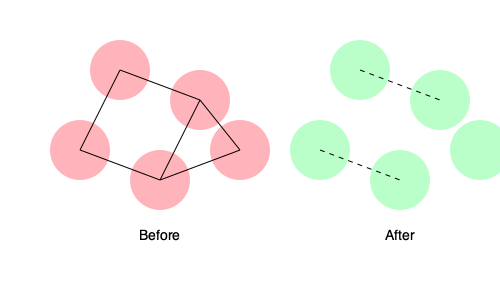Analyze the network topology changes before and after implementing social distancing measures. Calculate the reduction in network density and explain its implications for disease spread. To analyze the changes in network topology and calculate the reduction in network density:

1. Count the nodes and edges in each network:
   - Before: 5 nodes, 6 edges
   - After: 5 nodes, 2 edges

2. Calculate network density for each network using the formula:
   $$ \text{Density} = \frac{2E}{N(N-1)} $$
   Where $E$ is the number of edges and $N$ is the number of nodes.

3. Before social distancing:
   $$ \text{Density}_{\text{before}} = \frac{2 \times 6}{5(5-1)} = \frac{12}{20} = 0.6 $$

4. After social distancing:
   $$ \text{Density}_{\text{after}} = \frac{2 \times 2}{5(5-1)} = \frac{4}{20} = 0.2 $$

5. Calculate the reduction in network density:
   $$ \text{Reduction} = \text{Density}_{\text{before}} - \text{Density}_{\text{after}} = 0.6 - 0.2 = 0.4 $$

6. Calculate the percentage reduction:
   $$ \text{Percentage Reduction} = \frac{0.4}{0.6} \times 100\% \approx 66.67\% $$

Implications for disease spread:
- The significant reduction in network density (66.67%) indicates fewer connections between individuals.
- Fewer connections mean fewer potential transmission routes for the disease.
- The isolated nodes in the "After" network represent individuals with no direct contacts, reducing their risk of infection or spreading the disease.
- The remaining connections (dashed lines) may represent essential interactions that cannot be eliminated.
- Overall, the reduced network density suggests a lower probability of rapid disease spread within the population.
Answer: 66.67% reduction in network density, implying decreased disease transmission potential. 